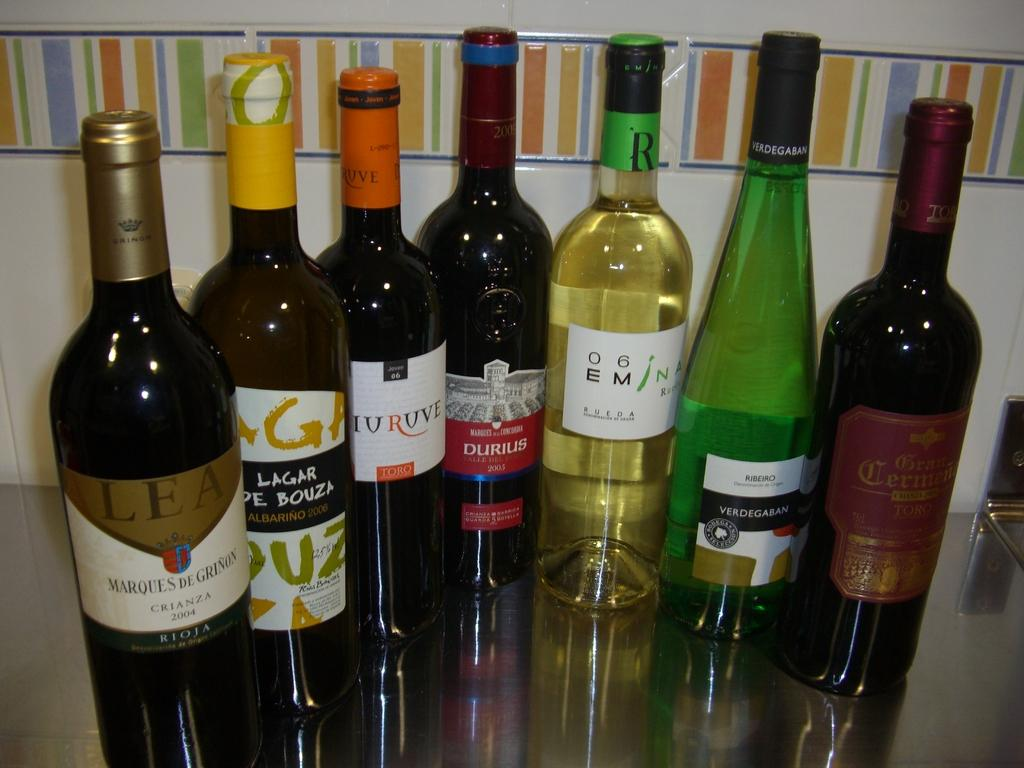<image>
Present a compact description of the photo's key features. Bottles of wine and alcohol arranged in a row with the letter R on one of them. 